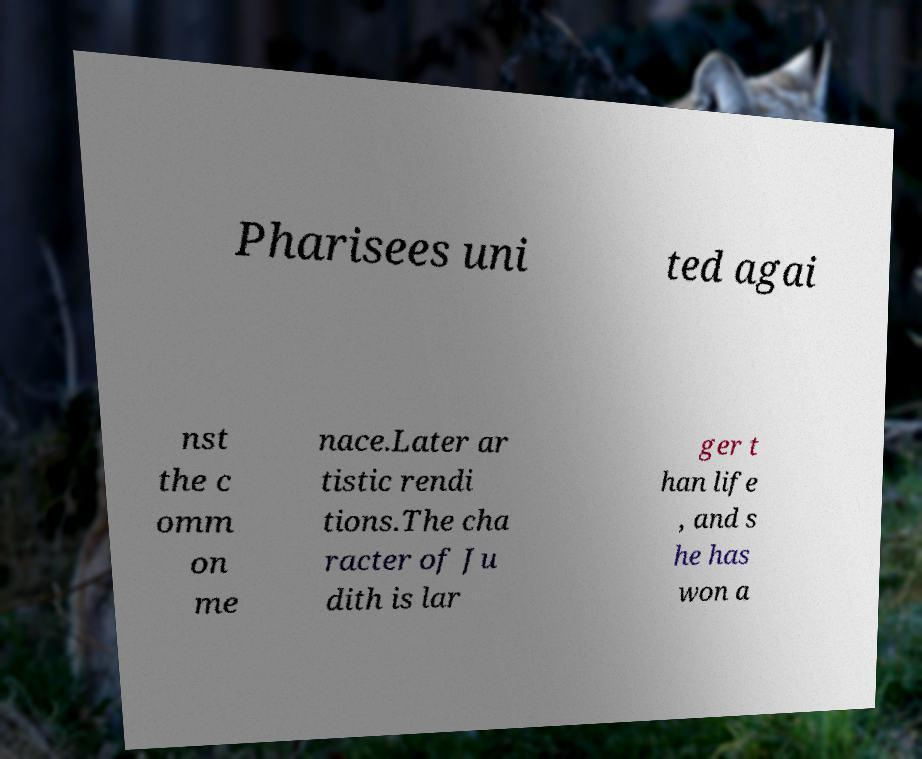Could you extract and type out the text from this image? Pharisees uni ted agai nst the c omm on me nace.Later ar tistic rendi tions.The cha racter of Ju dith is lar ger t han life , and s he has won a 